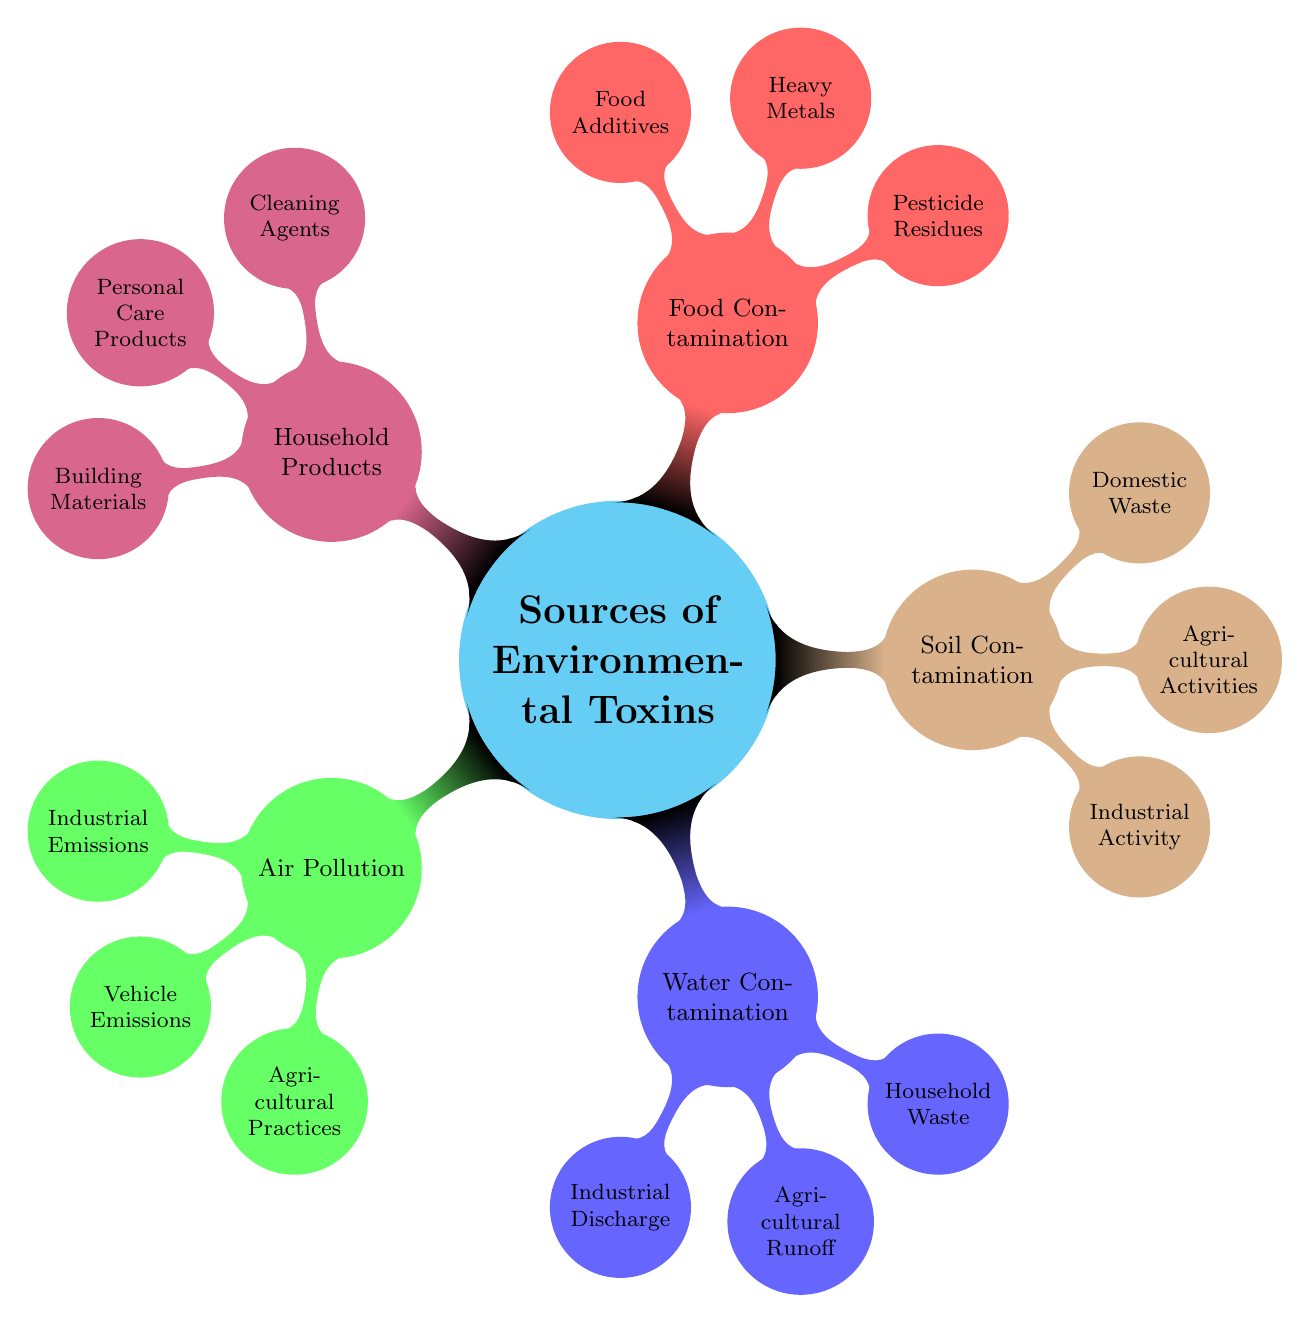What are the three main categories of sources of environmental toxins? The mind map lists Air Pollution, Water Contamination, Soil Contamination, Food Contamination, and Household Products as the main categories.
Answer: Air Pollution, Water Contamination, Soil Contamination, Food Contamination, Household Products How many child nodes are under Water Contamination? The Water Contamination node has three child nodes: Industrial Discharge, Agricultural Runoff, and Household Waste. Counting these gives a total of three nodes.
Answer: 3 Which factor contributes to Air Pollution and is related to transportation? The Vehicle Emissions node under Air Pollution leads to the factor specifically related to transportation, which includes Cars and Trucks.
Answer: Vehicle Emissions What kinds of contaminants are grouped under Food Contamination? The Food Contamination category includes Pesticide Residues, Heavy Metals, and Food Additives. This indicates the types of contaminants found in food.
Answer: Pesticide Residues, Heavy Metals, Food Additives How many sources are listed under Soil Contamination? There are three sources listed: Industrial Activity, Agricultural Activities, and Domestic Waste, making a total of three sources within the Soil Contamination category.
Answer: 3 Which source of environmental toxins includes the use of cleaning products? The Household Products category specifically highlights Cleaning Agents, along with other related products such as Personal Care Products and Building Materials.
Answer: Household Products What environmental sources result in contamination through runoff? Agricultural Runoff is specifically mentioned under Water Contamination as a source that leads to contamination through runoff stemming from agricultural practices.
Answer: Agricultural Runoff Which main category includes the cleaning agents like bleach and ammonia-based cleaners? Cleaning Agents are listed under the Household Products category, indicating that they fall within this broader classification.
Answer: Household Products What type of contamination is associated with pesticides and fertilizers? Air Pollution includes Agricultural Practices that prominently feature both Pesticides and Fertilizers as contributing factors to environmental toxins.
Answer: Air Pollution 